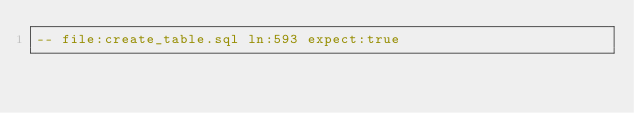Convert code to text. <code><loc_0><loc_0><loc_500><loc_500><_SQL_>-- file:create_table.sql ln:593 expect:true</code> 